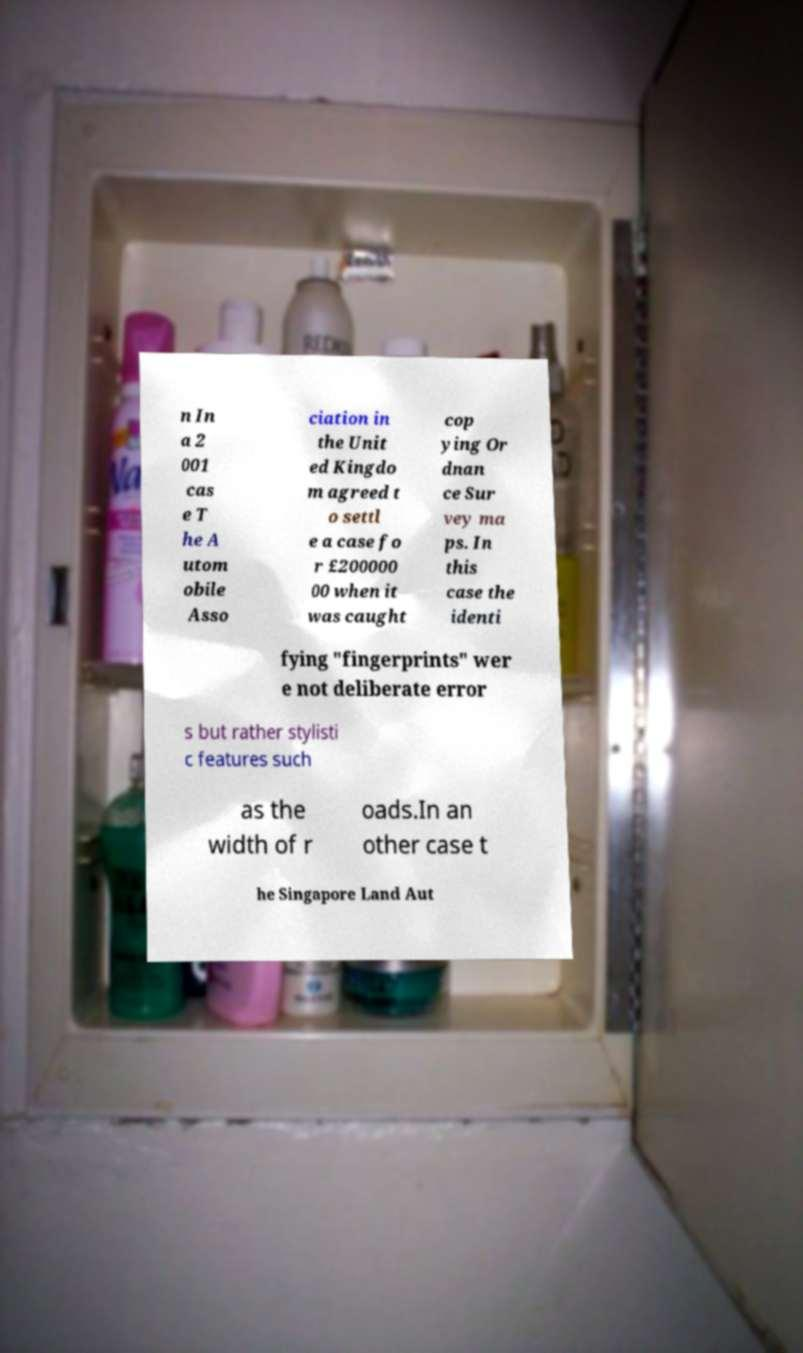Could you extract and type out the text from this image? n In a 2 001 cas e T he A utom obile Asso ciation in the Unit ed Kingdo m agreed t o settl e a case fo r £200000 00 when it was caught cop ying Or dnan ce Sur vey ma ps. In this case the identi fying "fingerprints" wer e not deliberate error s but rather stylisti c features such as the width of r oads.In an other case t he Singapore Land Aut 